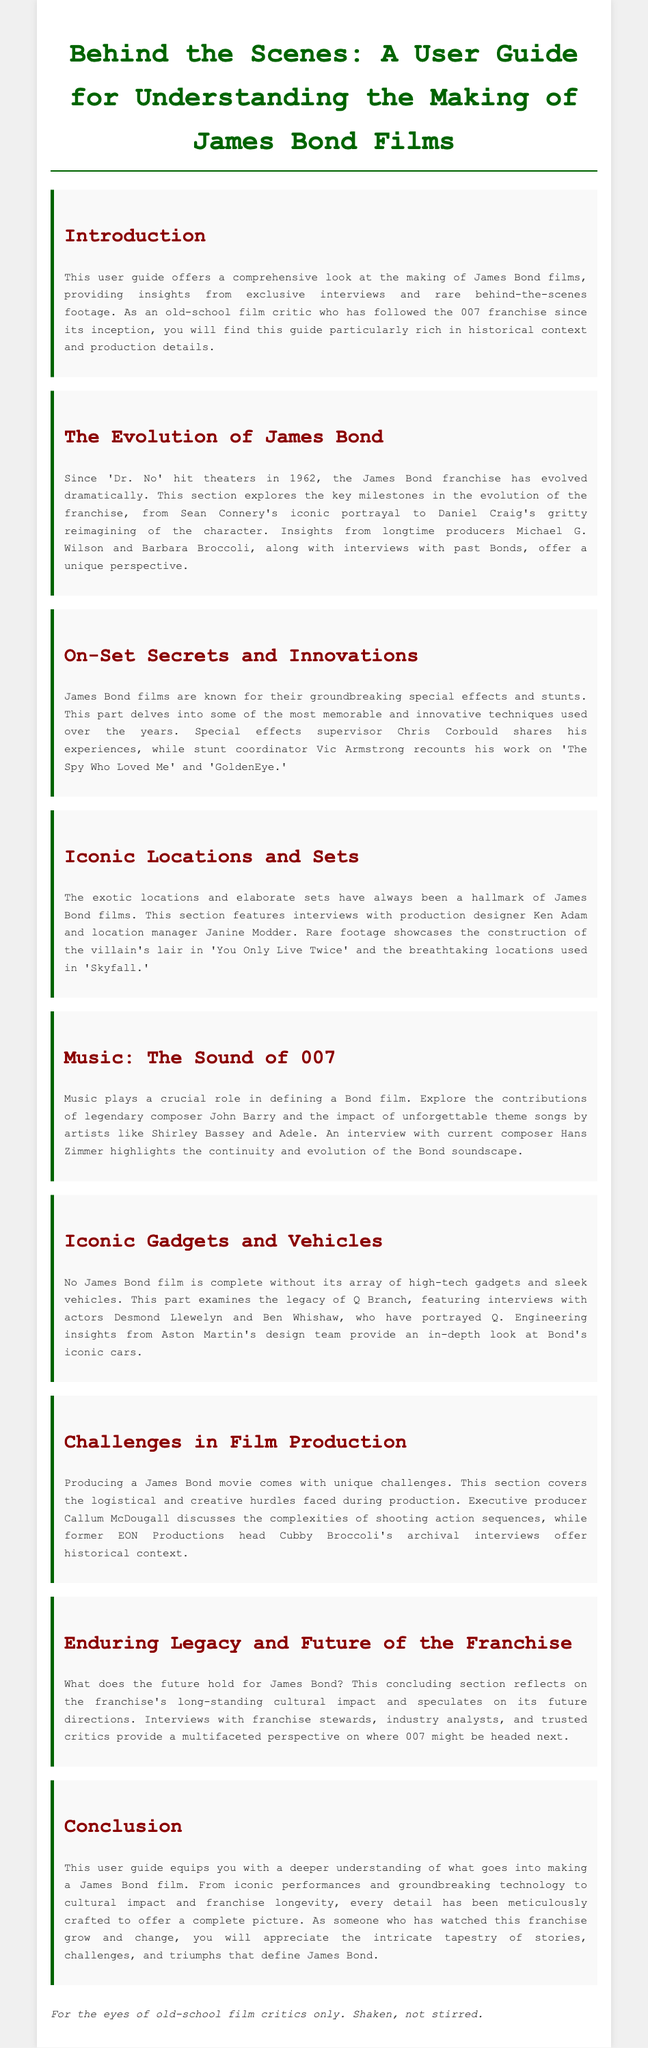What is the title of the user guide? The title of the user guide is mentioned at the top of the document.
Answer: Behind the Scenes: A User Guide for Understanding the Making of James Bond Films Who are the current producers mentioned in the document? The guide references longtime producers who have been involved in the franchise.
Answer: Michael G. Wilson and Barbara Broccoli Which James Bond film is highlighted for its groundbreaking special effects? Stunt coordinator Vic Armstrong's work on a specific film is discussed.
Answer: The Spy Who Loved Me What is the name of the composer highlighted in the music section? The document identifies a legendary composer associated with Bond films.
Answer: John Barry What year did 'Dr. No' premiere? The document states the release year of the first Bond film.
Answer: 1962 Which actor portrayed Q in the latest films? The guide discusses actors who played Q in the franchise.
Answer: Ben Whishaw What is a significant challenge mentioned in film production? The document covers various difficulties in making James Bond films.
Answer: Logistical hurdles What does the conclusion of the user guide emphasize? The conclusion summarizes the purpose and depth of the guide.
Answer: Deeper understanding of making a James Bond film What theme does the section on music explore? The music section focuses on a specific aspect of Bond films.
Answer: The sound of 007 